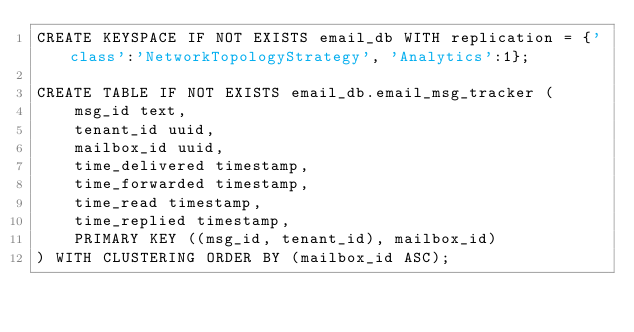Convert code to text. <code><loc_0><loc_0><loc_500><loc_500><_SQL_>CREATE KEYSPACE IF NOT EXISTS email_db WITH replication = {'class':'NetworkTopologyStrategy', 'Analytics':1};

CREATE TABLE IF NOT EXISTS email_db.email_msg_tracker (
    msg_id text,
    tenant_id uuid,
    mailbox_id uuid,
    time_delivered timestamp,
    time_forwarded timestamp,
    time_read timestamp,
    time_replied timestamp,
    PRIMARY KEY ((msg_id, tenant_id), mailbox_id)
) WITH CLUSTERING ORDER BY (mailbox_id ASC);
</code> 